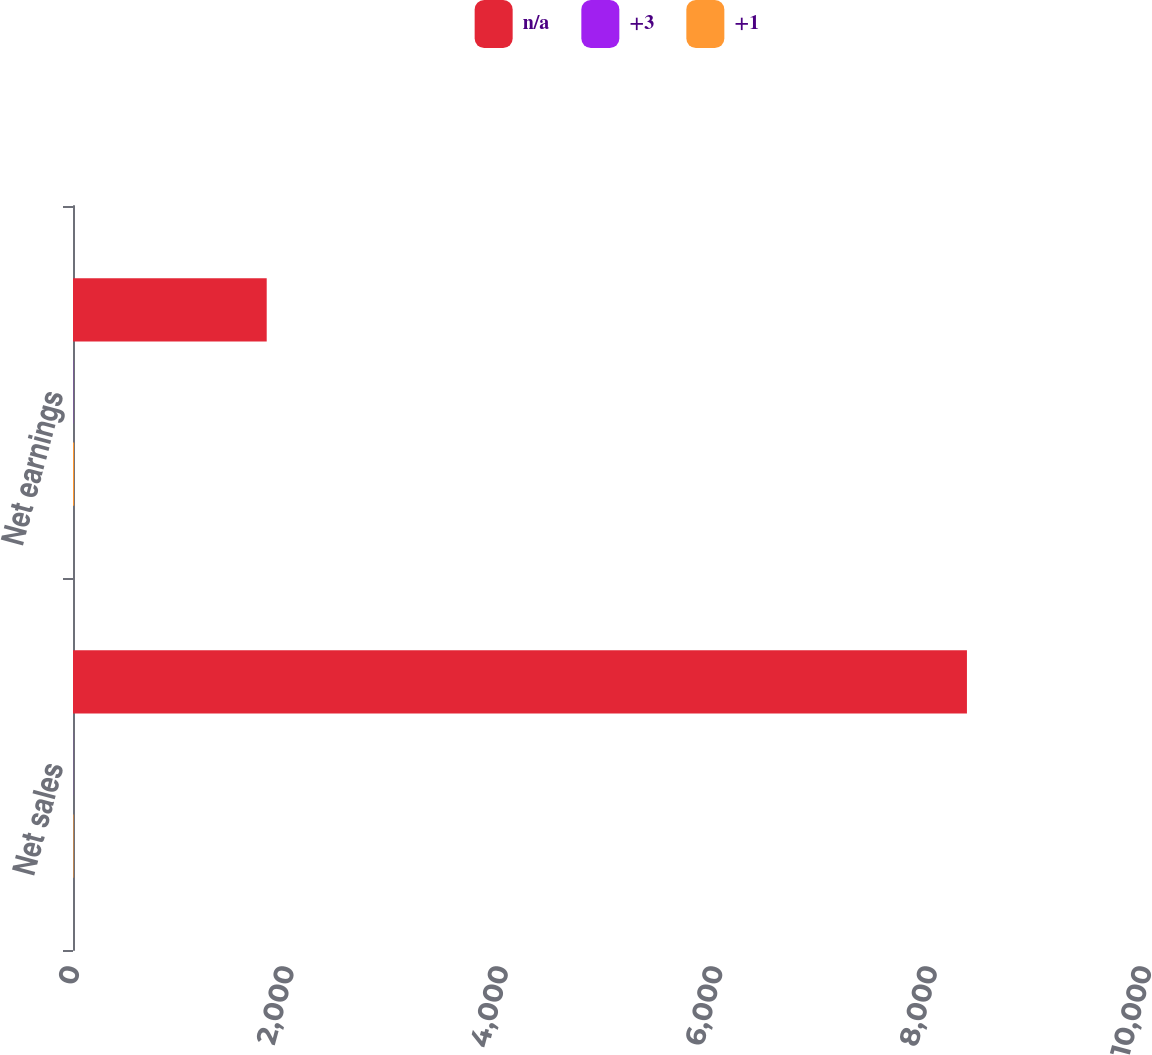Convert chart. <chart><loc_0><loc_0><loc_500><loc_500><stacked_bar_chart><ecel><fcel>Net sales<fcel>Net earnings<nl><fcel>nan<fcel>8339<fcel>1807<nl><fcel>3<fcel>1<fcel>2<nl><fcel>1<fcel>5<fcel>10<nl></chart> 